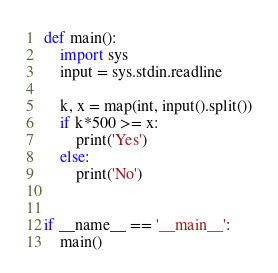Convert code to text. <code><loc_0><loc_0><loc_500><loc_500><_Python_>def main():
    import sys
    input = sys.stdin.readline

    k, x = map(int, input().split())
    if k*500 >= x:
        print('Yes')
    else:
        print('No')


if __name__ == '__main__':
    main()
</code> 